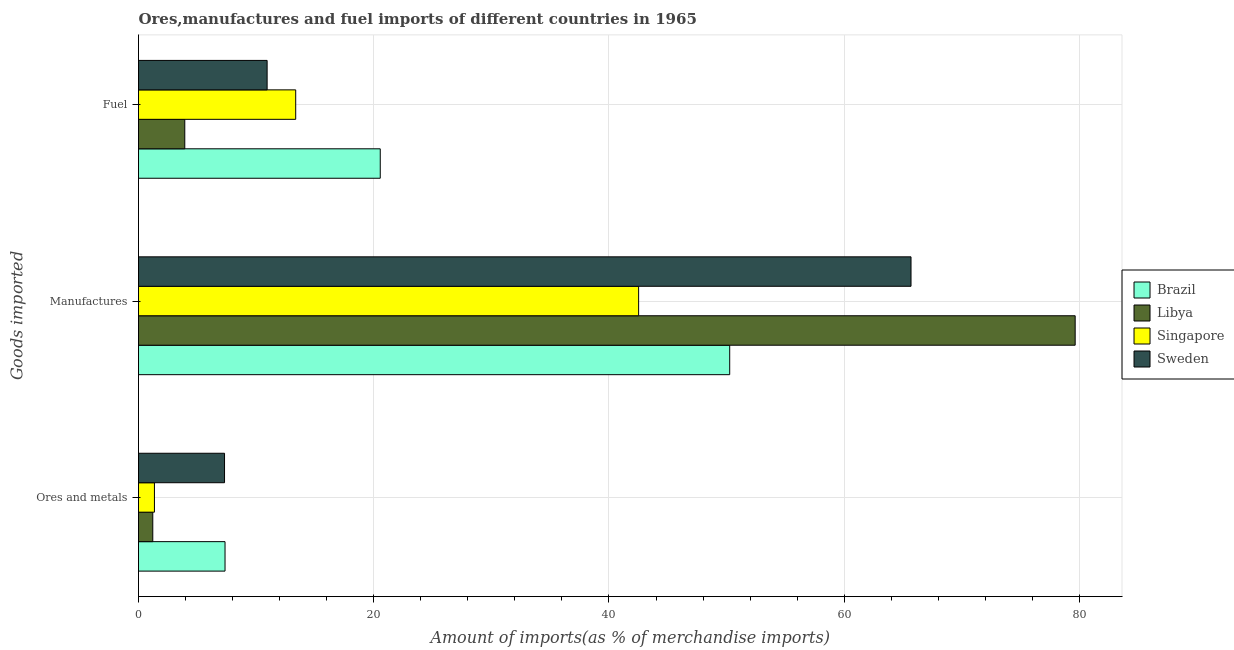How many groups of bars are there?
Make the answer very short. 3. How many bars are there on the 3rd tick from the top?
Provide a short and direct response. 4. What is the label of the 1st group of bars from the top?
Your answer should be very brief. Fuel. What is the percentage of manufactures imports in Libya?
Provide a succinct answer. 79.64. Across all countries, what is the maximum percentage of manufactures imports?
Your answer should be compact. 79.64. Across all countries, what is the minimum percentage of manufactures imports?
Give a very brief answer. 42.52. In which country was the percentage of manufactures imports maximum?
Offer a terse response. Libya. In which country was the percentage of manufactures imports minimum?
Your response must be concise. Singapore. What is the total percentage of manufactures imports in the graph?
Provide a succinct answer. 238.11. What is the difference between the percentage of fuel imports in Brazil and that in Sweden?
Offer a terse response. 9.62. What is the difference between the percentage of manufactures imports in Singapore and the percentage of fuel imports in Sweden?
Make the answer very short. 31.59. What is the average percentage of ores and metals imports per country?
Offer a terse response. 4.31. What is the difference between the percentage of fuel imports and percentage of manufactures imports in Brazil?
Ensure brevity in your answer.  -29.71. In how many countries, is the percentage of ores and metals imports greater than 8 %?
Make the answer very short. 0. What is the ratio of the percentage of ores and metals imports in Brazil to that in Sweden?
Your response must be concise. 1.01. Is the percentage of fuel imports in Brazil less than that in Sweden?
Your answer should be very brief. No. What is the difference between the highest and the second highest percentage of fuel imports?
Offer a very short reply. 7.19. What is the difference between the highest and the lowest percentage of manufactures imports?
Keep it short and to the point. 37.12. In how many countries, is the percentage of ores and metals imports greater than the average percentage of ores and metals imports taken over all countries?
Offer a terse response. 2. Is the sum of the percentage of fuel imports in Brazil and Singapore greater than the maximum percentage of manufactures imports across all countries?
Your answer should be very brief. No. What does the 2nd bar from the top in Manufactures represents?
Make the answer very short. Singapore. Are all the bars in the graph horizontal?
Keep it short and to the point. Yes. Are the values on the major ticks of X-axis written in scientific E-notation?
Provide a succinct answer. No. Does the graph contain any zero values?
Make the answer very short. No. Does the graph contain grids?
Make the answer very short. Yes. Where does the legend appear in the graph?
Offer a terse response. Center right. How many legend labels are there?
Provide a succinct answer. 4. How are the legend labels stacked?
Ensure brevity in your answer.  Vertical. What is the title of the graph?
Ensure brevity in your answer.  Ores,manufactures and fuel imports of different countries in 1965. Does "Guam" appear as one of the legend labels in the graph?
Make the answer very short. No. What is the label or title of the X-axis?
Your answer should be compact. Amount of imports(as % of merchandise imports). What is the label or title of the Y-axis?
Provide a succinct answer. Goods imported. What is the Amount of imports(as % of merchandise imports) of Brazil in Ores and metals?
Offer a terse response. 7.36. What is the Amount of imports(as % of merchandise imports) in Libya in Ores and metals?
Make the answer very short. 1.21. What is the Amount of imports(as % of merchandise imports) of Singapore in Ores and metals?
Give a very brief answer. 1.35. What is the Amount of imports(as % of merchandise imports) in Sweden in Ores and metals?
Offer a very short reply. 7.31. What is the Amount of imports(as % of merchandise imports) in Brazil in Manufactures?
Make the answer very short. 50.27. What is the Amount of imports(as % of merchandise imports) in Libya in Manufactures?
Your answer should be very brief. 79.64. What is the Amount of imports(as % of merchandise imports) in Singapore in Manufactures?
Make the answer very short. 42.52. What is the Amount of imports(as % of merchandise imports) in Sweden in Manufactures?
Keep it short and to the point. 65.68. What is the Amount of imports(as % of merchandise imports) of Brazil in Fuel?
Give a very brief answer. 20.55. What is the Amount of imports(as % of merchandise imports) in Libya in Fuel?
Offer a terse response. 3.93. What is the Amount of imports(as % of merchandise imports) of Singapore in Fuel?
Offer a very short reply. 13.37. What is the Amount of imports(as % of merchandise imports) in Sweden in Fuel?
Offer a very short reply. 10.93. Across all Goods imported, what is the maximum Amount of imports(as % of merchandise imports) of Brazil?
Offer a very short reply. 50.27. Across all Goods imported, what is the maximum Amount of imports(as % of merchandise imports) of Libya?
Ensure brevity in your answer.  79.64. Across all Goods imported, what is the maximum Amount of imports(as % of merchandise imports) of Singapore?
Make the answer very short. 42.52. Across all Goods imported, what is the maximum Amount of imports(as % of merchandise imports) in Sweden?
Keep it short and to the point. 65.68. Across all Goods imported, what is the minimum Amount of imports(as % of merchandise imports) of Brazil?
Give a very brief answer. 7.36. Across all Goods imported, what is the minimum Amount of imports(as % of merchandise imports) of Libya?
Offer a very short reply. 1.21. Across all Goods imported, what is the minimum Amount of imports(as % of merchandise imports) of Singapore?
Provide a short and direct response. 1.35. Across all Goods imported, what is the minimum Amount of imports(as % of merchandise imports) of Sweden?
Keep it short and to the point. 7.31. What is the total Amount of imports(as % of merchandise imports) in Brazil in the graph?
Give a very brief answer. 78.18. What is the total Amount of imports(as % of merchandise imports) of Libya in the graph?
Your response must be concise. 84.79. What is the total Amount of imports(as % of merchandise imports) in Singapore in the graph?
Offer a very short reply. 57.24. What is the total Amount of imports(as % of merchandise imports) in Sweden in the graph?
Your answer should be very brief. 83.93. What is the difference between the Amount of imports(as % of merchandise imports) of Brazil in Ores and metals and that in Manufactures?
Provide a short and direct response. -42.91. What is the difference between the Amount of imports(as % of merchandise imports) of Libya in Ores and metals and that in Manufactures?
Ensure brevity in your answer.  -78.43. What is the difference between the Amount of imports(as % of merchandise imports) in Singapore in Ores and metals and that in Manufactures?
Offer a very short reply. -41.17. What is the difference between the Amount of imports(as % of merchandise imports) of Sweden in Ores and metals and that in Manufactures?
Your answer should be very brief. -58.37. What is the difference between the Amount of imports(as % of merchandise imports) of Brazil in Ores and metals and that in Fuel?
Offer a terse response. -13.2. What is the difference between the Amount of imports(as % of merchandise imports) of Libya in Ores and metals and that in Fuel?
Ensure brevity in your answer.  -2.72. What is the difference between the Amount of imports(as % of merchandise imports) in Singapore in Ores and metals and that in Fuel?
Your answer should be very brief. -12.01. What is the difference between the Amount of imports(as % of merchandise imports) of Sweden in Ores and metals and that in Fuel?
Offer a terse response. -3.62. What is the difference between the Amount of imports(as % of merchandise imports) of Brazil in Manufactures and that in Fuel?
Your response must be concise. 29.71. What is the difference between the Amount of imports(as % of merchandise imports) of Libya in Manufactures and that in Fuel?
Your answer should be very brief. 75.71. What is the difference between the Amount of imports(as % of merchandise imports) of Singapore in Manufactures and that in Fuel?
Your response must be concise. 29.16. What is the difference between the Amount of imports(as % of merchandise imports) of Sweden in Manufactures and that in Fuel?
Give a very brief answer. 54.75. What is the difference between the Amount of imports(as % of merchandise imports) of Brazil in Ores and metals and the Amount of imports(as % of merchandise imports) of Libya in Manufactures?
Offer a very short reply. -72.28. What is the difference between the Amount of imports(as % of merchandise imports) in Brazil in Ores and metals and the Amount of imports(as % of merchandise imports) in Singapore in Manufactures?
Offer a terse response. -35.16. What is the difference between the Amount of imports(as % of merchandise imports) of Brazil in Ores and metals and the Amount of imports(as % of merchandise imports) of Sweden in Manufactures?
Make the answer very short. -58.33. What is the difference between the Amount of imports(as % of merchandise imports) of Libya in Ores and metals and the Amount of imports(as % of merchandise imports) of Singapore in Manufactures?
Make the answer very short. -41.31. What is the difference between the Amount of imports(as % of merchandise imports) in Libya in Ores and metals and the Amount of imports(as % of merchandise imports) in Sweden in Manufactures?
Give a very brief answer. -64.47. What is the difference between the Amount of imports(as % of merchandise imports) of Singapore in Ores and metals and the Amount of imports(as % of merchandise imports) of Sweden in Manufactures?
Provide a succinct answer. -64.33. What is the difference between the Amount of imports(as % of merchandise imports) in Brazil in Ores and metals and the Amount of imports(as % of merchandise imports) in Libya in Fuel?
Ensure brevity in your answer.  3.42. What is the difference between the Amount of imports(as % of merchandise imports) of Brazil in Ores and metals and the Amount of imports(as % of merchandise imports) of Singapore in Fuel?
Your answer should be very brief. -6.01. What is the difference between the Amount of imports(as % of merchandise imports) of Brazil in Ores and metals and the Amount of imports(as % of merchandise imports) of Sweden in Fuel?
Provide a short and direct response. -3.58. What is the difference between the Amount of imports(as % of merchandise imports) in Libya in Ores and metals and the Amount of imports(as % of merchandise imports) in Singapore in Fuel?
Your answer should be compact. -12.15. What is the difference between the Amount of imports(as % of merchandise imports) of Libya in Ores and metals and the Amount of imports(as % of merchandise imports) of Sweden in Fuel?
Offer a terse response. -9.72. What is the difference between the Amount of imports(as % of merchandise imports) in Singapore in Ores and metals and the Amount of imports(as % of merchandise imports) in Sweden in Fuel?
Provide a short and direct response. -9.58. What is the difference between the Amount of imports(as % of merchandise imports) in Brazil in Manufactures and the Amount of imports(as % of merchandise imports) in Libya in Fuel?
Give a very brief answer. 46.33. What is the difference between the Amount of imports(as % of merchandise imports) in Brazil in Manufactures and the Amount of imports(as % of merchandise imports) in Singapore in Fuel?
Your answer should be very brief. 36.9. What is the difference between the Amount of imports(as % of merchandise imports) of Brazil in Manufactures and the Amount of imports(as % of merchandise imports) of Sweden in Fuel?
Make the answer very short. 39.33. What is the difference between the Amount of imports(as % of merchandise imports) in Libya in Manufactures and the Amount of imports(as % of merchandise imports) in Singapore in Fuel?
Your answer should be compact. 66.27. What is the difference between the Amount of imports(as % of merchandise imports) in Libya in Manufactures and the Amount of imports(as % of merchandise imports) in Sweden in Fuel?
Your answer should be very brief. 68.7. What is the difference between the Amount of imports(as % of merchandise imports) in Singapore in Manufactures and the Amount of imports(as % of merchandise imports) in Sweden in Fuel?
Give a very brief answer. 31.59. What is the average Amount of imports(as % of merchandise imports) in Brazil per Goods imported?
Your response must be concise. 26.06. What is the average Amount of imports(as % of merchandise imports) in Libya per Goods imported?
Your answer should be compact. 28.26. What is the average Amount of imports(as % of merchandise imports) in Singapore per Goods imported?
Offer a very short reply. 19.08. What is the average Amount of imports(as % of merchandise imports) in Sweden per Goods imported?
Offer a very short reply. 27.98. What is the difference between the Amount of imports(as % of merchandise imports) in Brazil and Amount of imports(as % of merchandise imports) in Libya in Ores and metals?
Your answer should be compact. 6.14. What is the difference between the Amount of imports(as % of merchandise imports) of Brazil and Amount of imports(as % of merchandise imports) of Singapore in Ores and metals?
Offer a terse response. 6. What is the difference between the Amount of imports(as % of merchandise imports) of Brazil and Amount of imports(as % of merchandise imports) of Sweden in Ores and metals?
Offer a terse response. 0.04. What is the difference between the Amount of imports(as % of merchandise imports) of Libya and Amount of imports(as % of merchandise imports) of Singapore in Ores and metals?
Provide a short and direct response. -0.14. What is the difference between the Amount of imports(as % of merchandise imports) of Singapore and Amount of imports(as % of merchandise imports) of Sweden in Ores and metals?
Offer a very short reply. -5.96. What is the difference between the Amount of imports(as % of merchandise imports) in Brazil and Amount of imports(as % of merchandise imports) in Libya in Manufactures?
Your response must be concise. -29.37. What is the difference between the Amount of imports(as % of merchandise imports) of Brazil and Amount of imports(as % of merchandise imports) of Singapore in Manufactures?
Give a very brief answer. 7.75. What is the difference between the Amount of imports(as % of merchandise imports) in Brazil and Amount of imports(as % of merchandise imports) in Sweden in Manufactures?
Provide a succinct answer. -15.42. What is the difference between the Amount of imports(as % of merchandise imports) in Libya and Amount of imports(as % of merchandise imports) in Singapore in Manufactures?
Offer a terse response. 37.12. What is the difference between the Amount of imports(as % of merchandise imports) in Libya and Amount of imports(as % of merchandise imports) in Sweden in Manufactures?
Keep it short and to the point. 13.96. What is the difference between the Amount of imports(as % of merchandise imports) in Singapore and Amount of imports(as % of merchandise imports) in Sweden in Manufactures?
Make the answer very short. -23.16. What is the difference between the Amount of imports(as % of merchandise imports) of Brazil and Amount of imports(as % of merchandise imports) of Libya in Fuel?
Offer a terse response. 16.62. What is the difference between the Amount of imports(as % of merchandise imports) in Brazil and Amount of imports(as % of merchandise imports) in Singapore in Fuel?
Provide a short and direct response. 7.19. What is the difference between the Amount of imports(as % of merchandise imports) of Brazil and Amount of imports(as % of merchandise imports) of Sweden in Fuel?
Your answer should be compact. 9.62. What is the difference between the Amount of imports(as % of merchandise imports) of Libya and Amount of imports(as % of merchandise imports) of Singapore in Fuel?
Your answer should be compact. -9.43. What is the difference between the Amount of imports(as % of merchandise imports) in Libya and Amount of imports(as % of merchandise imports) in Sweden in Fuel?
Provide a succinct answer. -7. What is the difference between the Amount of imports(as % of merchandise imports) of Singapore and Amount of imports(as % of merchandise imports) of Sweden in Fuel?
Your answer should be compact. 2.43. What is the ratio of the Amount of imports(as % of merchandise imports) of Brazil in Ores and metals to that in Manufactures?
Provide a succinct answer. 0.15. What is the ratio of the Amount of imports(as % of merchandise imports) of Libya in Ores and metals to that in Manufactures?
Your answer should be very brief. 0.02. What is the ratio of the Amount of imports(as % of merchandise imports) in Singapore in Ores and metals to that in Manufactures?
Your answer should be compact. 0.03. What is the ratio of the Amount of imports(as % of merchandise imports) of Sweden in Ores and metals to that in Manufactures?
Your response must be concise. 0.11. What is the ratio of the Amount of imports(as % of merchandise imports) of Brazil in Ores and metals to that in Fuel?
Your response must be concise. 0.36. What is the ratio of the Amount of imports(as % of merchandise imports) of Libya in Ores and metals to that in Fuel?
Offer a terse response. 0.31. What is the ratio of the Amount of imports(as % of merchandise imports) of Singapore in Ores and metals to that in Fuel?
Give a very brief answer. 0.1. What is the ratio of the Amount of imports(as % of merchandise imports) of Sweden in Ores and metals to that in Fuel?
Ensure brevity in your answer.  0.67. What is the ratio of the Amount of imports(as % of merchandise imports) of Brazil in Manufactures to that in Fuel?
Offer a very short reply. 2.45. What is the ratio of the Amount of imports(as % of merchandise imports) of Libya in Manufactures to that in Fuel?
Make the answer very short. 20.24. What is the ratio of the Amount of imports(as % of merchandise imports) of Singapore in Manufactures to that in Fuel?
Your answer should be very brief. 3.18. What is the ratio of the Amount of imports(as % of merchandise imports) in Sweden in Manufactures to that in Fuel?
Provide a succinct answer. 6.01. What is the difference between the highest and the second highest Amount of imports(as % of merchandise imports) in Brazil?
Your answer should be very brief. 29.71. What is the difference between the highest and the second highest Amount of imports(as % of merchandise imports) of Libya?
Ensure brevity in your answer.  75.71. What is the difference between the highest and the second highest Amount of imports(as % of merchandise imports) of Singapore?
Provide a short and direct response. 29.16. What is the difference between the highest and the second highest Amount of imports(as % of merchandise imports) of Sweden?
Keep it short and to the point. 54.75. What is the difference between the highest and the lowest Amount of imports(as % of merchandise imports) of Brazil?
Provide a succinct answer. 42.91. What is the difference between the highest and the lowest Amount of imports(as % of merchandise imports) in Libya?
Provide a short and direct response. 78.43. What is the difference between the highest and the lowest Amount of imports(as % of merchandise imports) of Singapore?
Offer a terse response. 41.17. What is the difference between the highest and the lowest Amount of imports(as % of merchandise imports) of Sweden?
Your answer should be very brief. 58.37. 